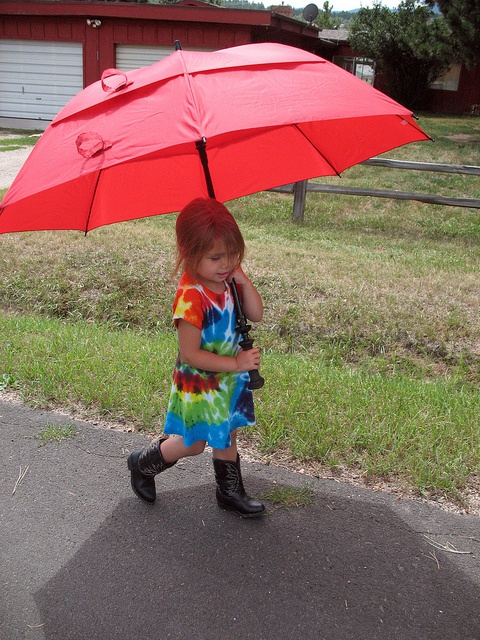Describe the objects in this image and their specific colors. I can see umbrella in black, red, lightpink, and salmon tones and people in black, maroon, brown, and blue tones in this image. 